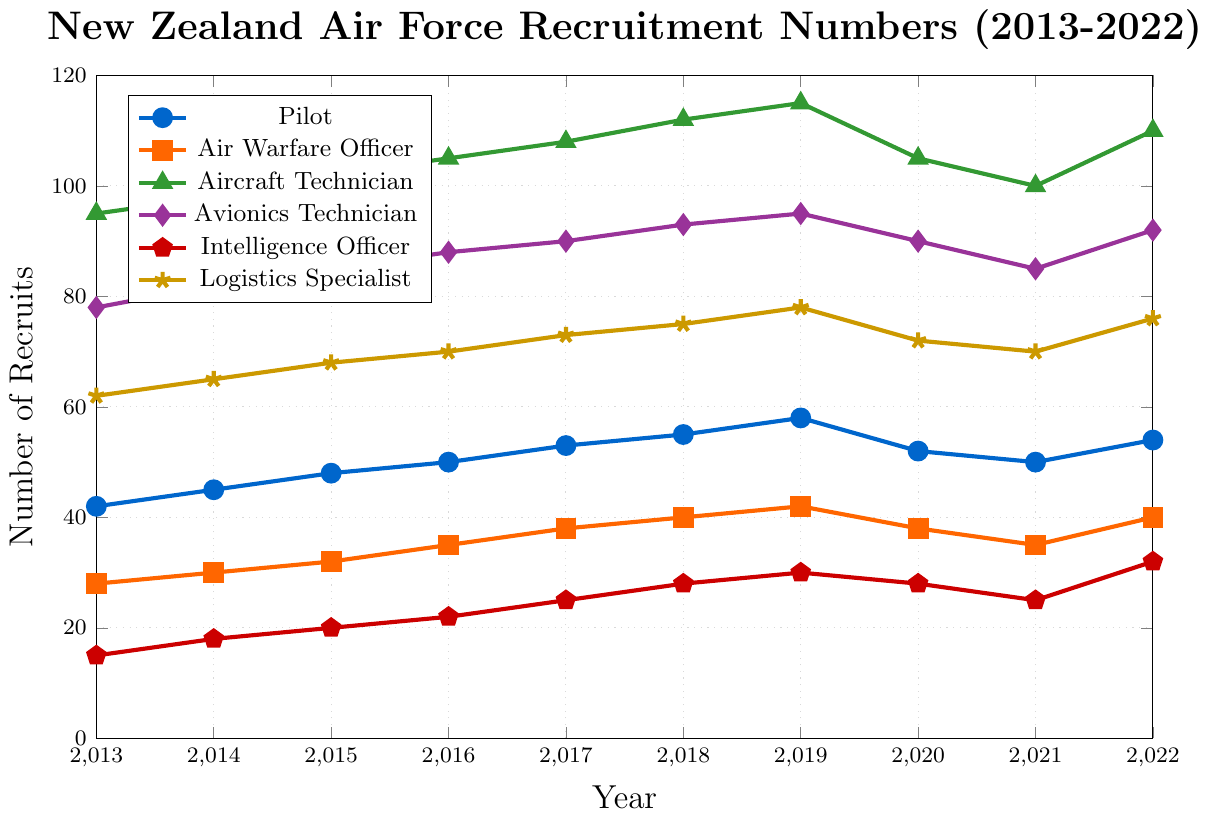Which role had the highest recruitment number in 2019? Look at the data points for all roles in 2019 and compare the heights to find the tallest one. The Aircraft Technician role has the highest value of 115.
Answer: Aircraft Technician By how much did the number of Avionics Technicians recruited change from 2013 to 2015? Find the values for Avionics Technicians in 2013 and 2015, which are 78 and 85 respectively. Calculate the difference: 85 - 78.
Answer: 7 Which role had the lowest recruitment number in 2020, and what was it? Look at the data points for all roles in 2020 and identify the lowest point. The Intelligence Officer role has the lowest value of 28.
Answer: Intelligence Officer, 28 Did any role experience a decrease in recruitment from 2019 to 2021? If yes, which ones? Look at the values from 2019 to 2021 for all roles to see if there was a decrease. Pilot (58 to 50), Air Warfare Officer (42 to 35), Aircraft Technician (115 to 100), Avionics Technician (95 to 85), Logistics Specialist (78 to 70) all experienced a decrease.
Answer: Pilot, Air Warfare Officer, Aircraft Technician, Avionics Technician, Logistics Specialist What is the average number of recruits for the Logistics Specialist role over the entire period? Sum the values for Logistics Specialist from 2013 to 2022: 62 + 65 + 68 + 70 + 73 + 75 + 78 + 72 + 70 + 76 = 709. Then, divide by the number of years (10).
Answer: 70.9 Which role saw the biggest overall increase in recruitment from 2013 to 2022? Subtract the 2013 value from the 2022 value for each role and compare. Pilot: 54 - 42 = 12, Air Warfare Officer: 40 - 28 = 12, Aircraft Technician: 110 - 95 = 15, Avionics Technician: 92 - 78 = 14, Intelligence Officer: 32 - 15 = 17, Logistics Specialist: 76 - 62 = 14. The Intelligence Officer role saw the biggest increase of 17.
Answer: Intelligence Officer In which year did the Pilot role reach its highest recruitment number and what was that number? Look at the values for the Pilot role across all years for the highest value, which is 58 in 2019.
Answer: 2019, 58 What was the sum of recruits for all roles in 2017? Add the values for all roles in 2017: 53 (Pilot) + 38 (Air Warfare Officer) + 108 (Aircraft Technician) + 90 (Avionics Technician) + 25 (Intelligence Officer) + 73 (Logistics Specialist) = 387.
Answer: 387 